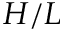<formula> <loc_0><loc_0><loc_500><loc_500>H / L</formula> 